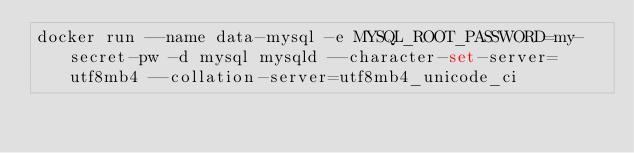<code> <loc_0><loc_0><loc_500><loc_500><_Bash_>docker run --name data-mysql -e MYSQL_ROOT_PASSWORD=my-secret-pw -d mysql mysqld --character-set-server=utf8mb4 --collation-server=utf8mb4_unicode_ci 
</code> 